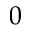<formula> <loc_0><loc_0><loc_500><loc_500>0</formula> 